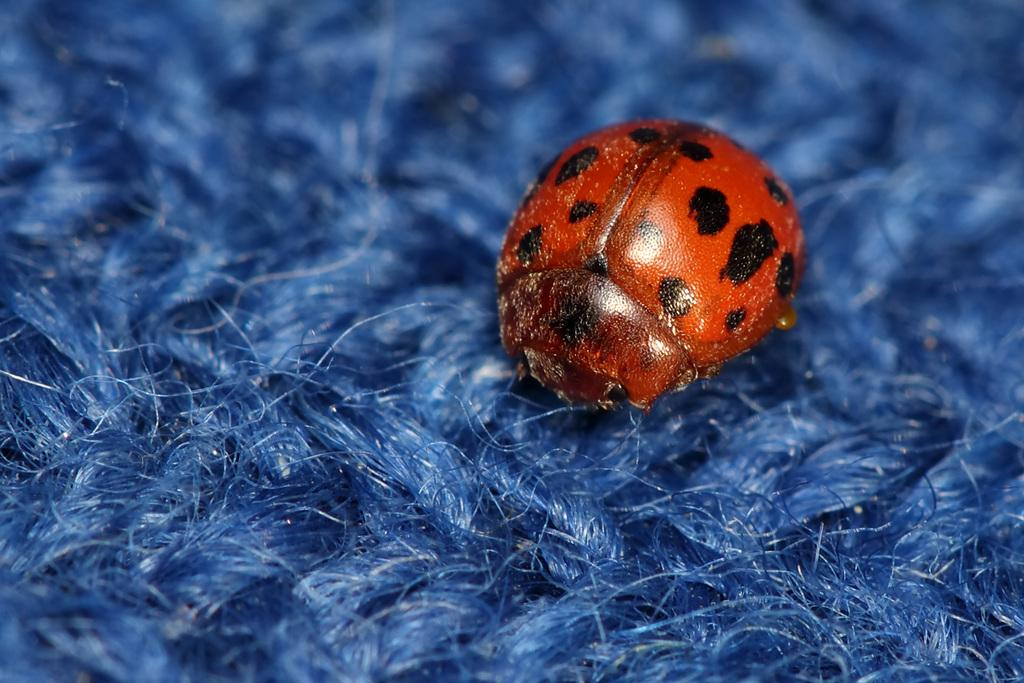What type of creature can be seen in the image? There is an insect in the image. What is the color of the insect? The insect is red in color. What other object is present in the image? There is a cloth in the image. What is the color of the cloth? The cloth is blue in color. What letter does the insect spell out with its body in the image? There is no indication that the insect is spelling out a letter with its body in the image. 